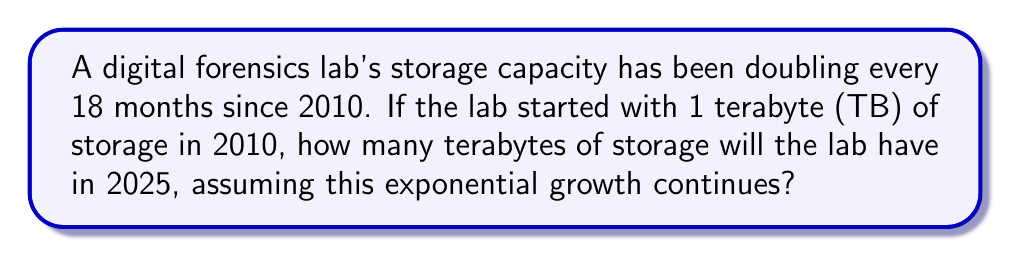Show me your answer to this math problem. Let's approach this step-by-step:

1) First, we need to determine how many 18-month periods there are between 2010 and 2025.
   - From 2010 to 2025 is 15 years
   - 15 years = 180 months
   - Number of 18-month periods = 180 ÷ 18 = 10

2) Now we can set up our exponential growth equation:
   $$ \text{Final Storage} = \text{Initial Storage} \times 2^n $$
   Where $n$ is the number of 18-month periods.

3) Plugging in our values:
   $$ \text{Final Storage} = 1 \text{ TB} \times 2^{10} $$

4) Calculate $2^{10}$:
   $$ 2^{10} = 1024 $$

5) Therefore:
   $$ \text{Final Storage} = 1 \text{ TB} \times 1024 = 1024 \text{ TB} $$

Thus, in 2025, the lab will have 1024 TB of storage capacity.
Answer: 1024 TB 